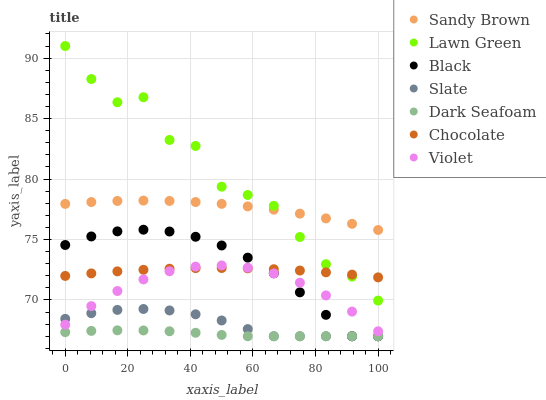Does Dark Seafoam have the minimum area under the curve?
Answer yes or no. Yes. Does Lawn Green have the maximum area under the curve?
Answer yes or no. Yes. Does Slate have the minimum area under the curve?
Answer yes or no. No. Does Slate have the maximum area under the curve?
Answer yes or no. No. Is Chocolate the smoothest?
Answer yes or no. Yes. Is Lawn Green the roughest?
Answer yes or no. Yes. Is Slate the smoothest?
Answer yes or no. No. Is Slate the roughest?
Answer yes or no. No. Does Slate have the lowest value?
Answer yes or no. Yes. Does Chocolate have the lowest value?
Answer yes or no. No. Does Lawn Green have the highest value?
Answer yes or no. Yes. Does Slate have the highest value?
Answer yes or no. No. Is Slate less than Chocolate?
Answer yes or no. Yes. Is Sandy Brown greater than Chocolate?
Answer yes or no. Yes. Does Black intersect Dark Seafoam?
Answer yes or no. Yes. Is Black less than Dark Seafoam?
Answer yes or no. No. Is Black greater than Dark Seafoam?
Answer yes or no. No. Does Slate intersect Chocolate?
Answer yes or no. No. 